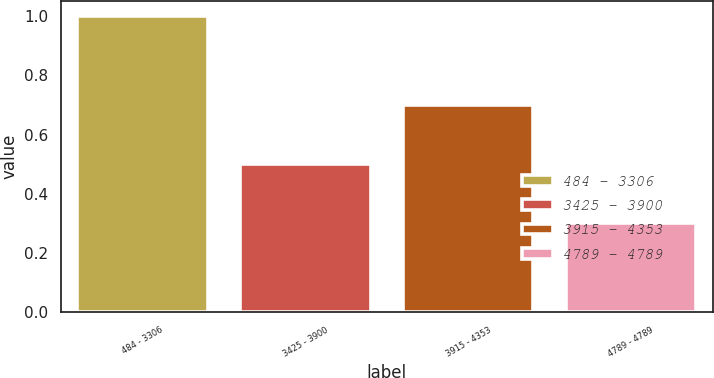Convert chart to OTSL. <chart><loc_0><loc_0><loc_500><loc_500><bar_chart><fcel>484 - 3306<fcel>3425 - 3900<fcel>3915 - 4353<fcel>4789 - 4789<nl><fcel>1<fcel>0.5<fcel>0.7<fcel>0.3<nl></chart> 